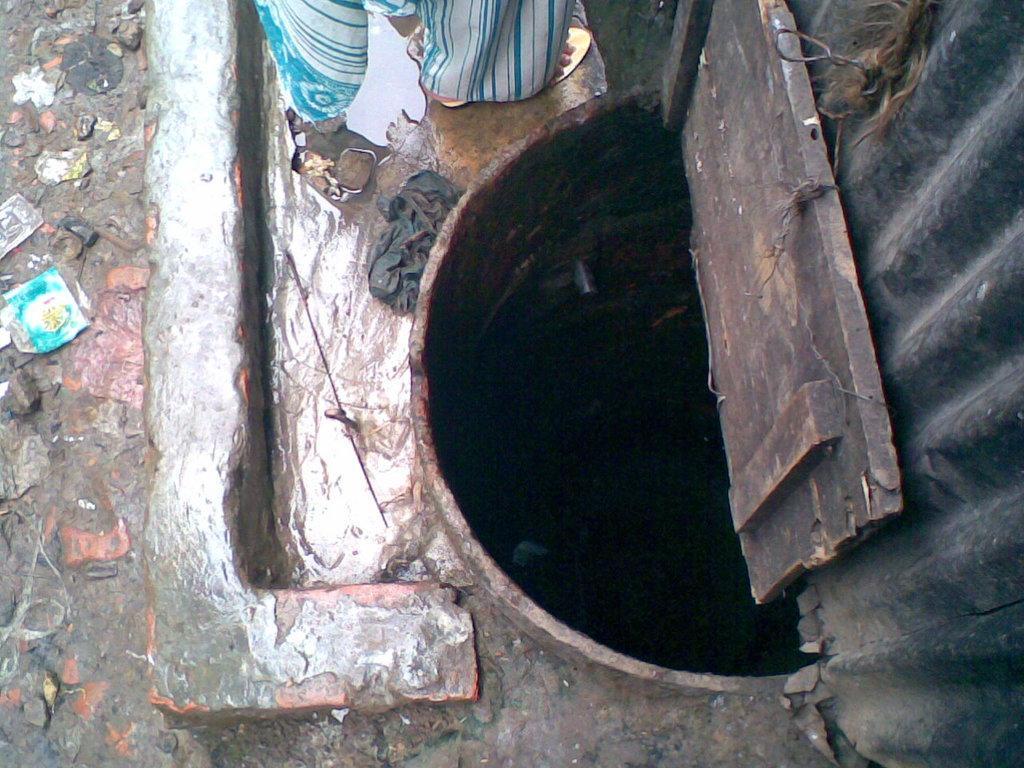In one or two sentences, can you explain what this image depicts? There is a well which is opened, near a wall and a person who is on the floor. On the left side, there are covers on a road. 